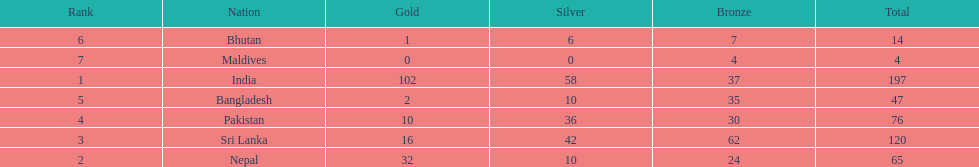What country has won no silver medals? Maldives. 